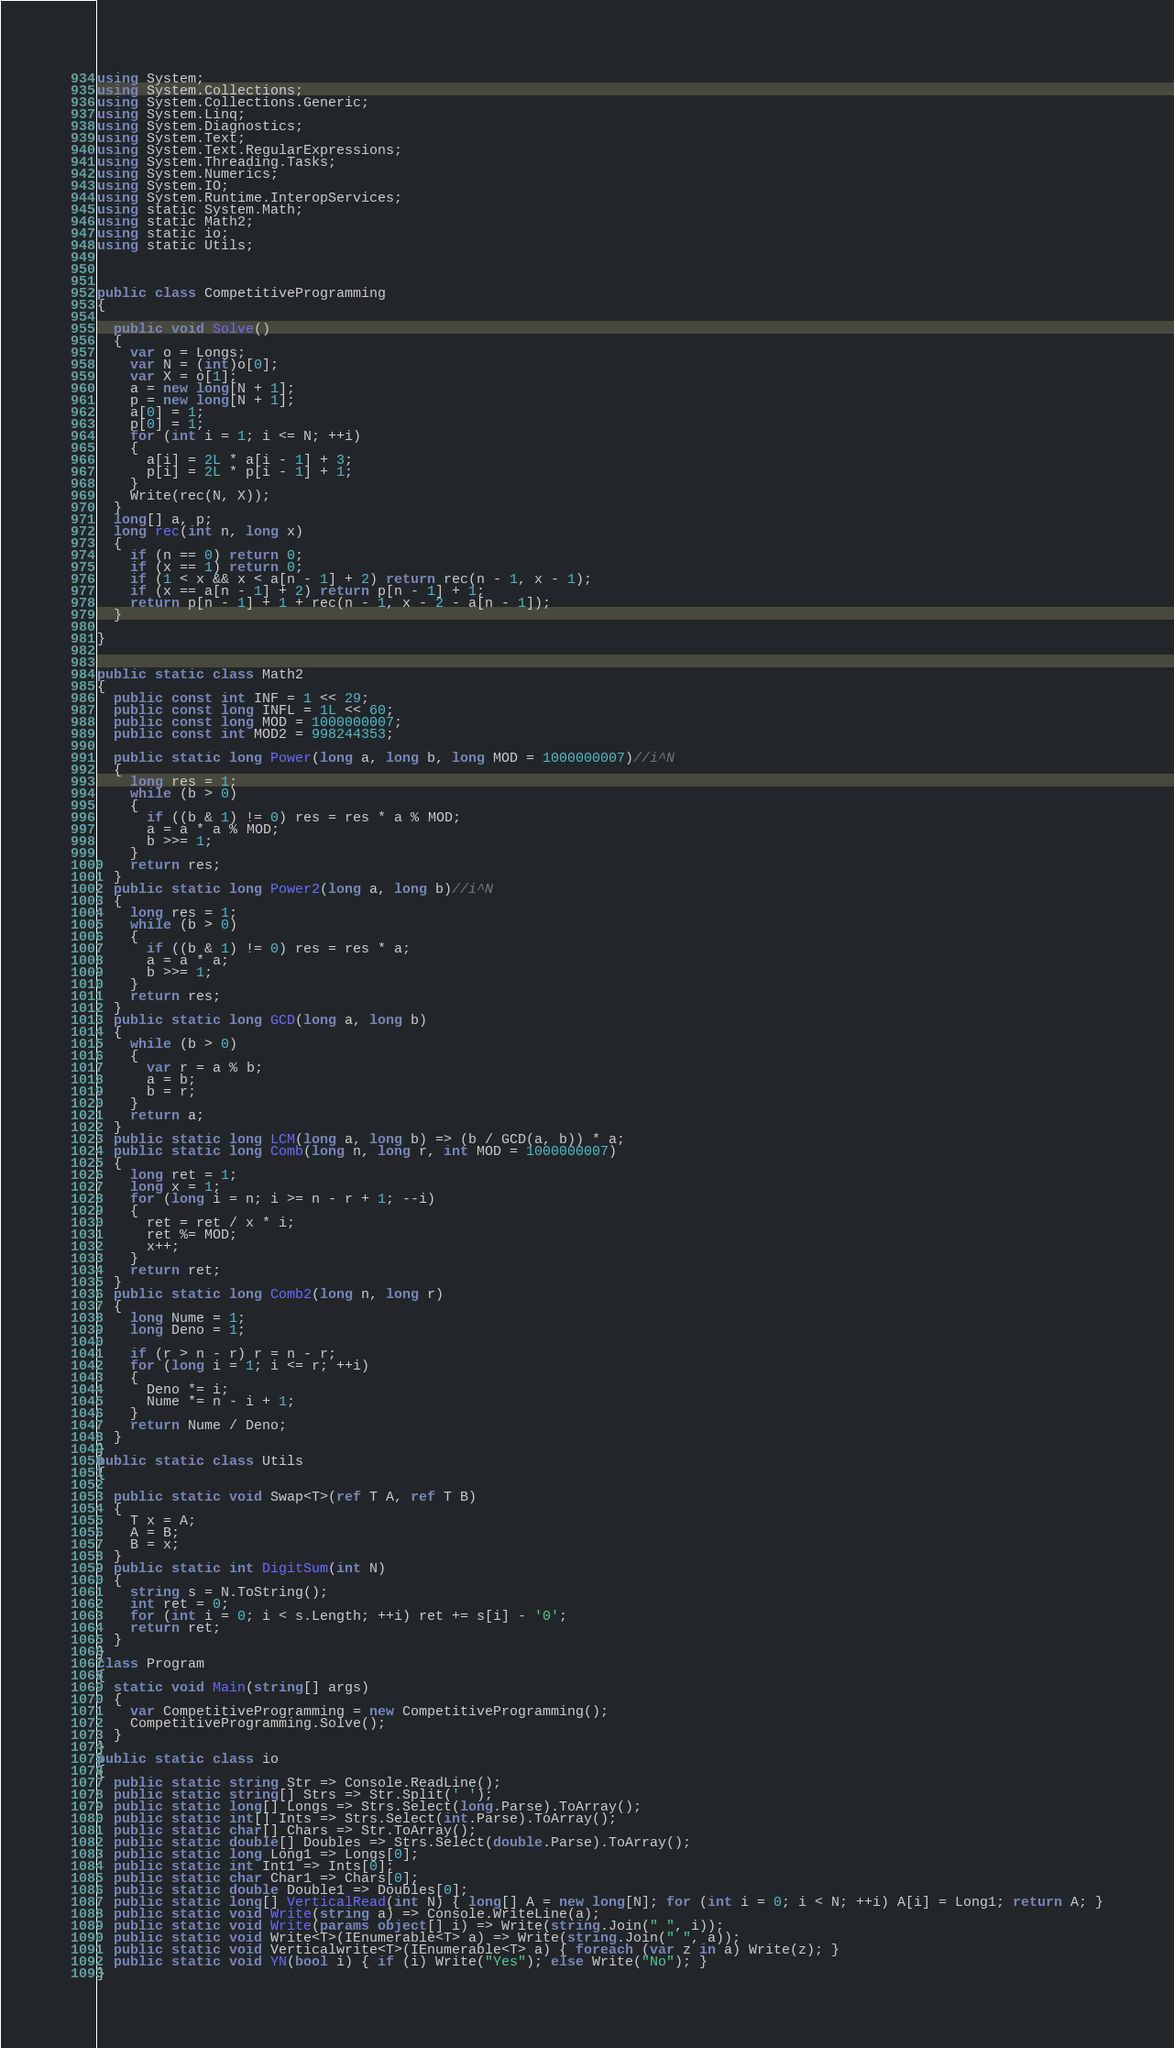<code> <loc_0><loc_0><loc_500><loc_500><_C#_>using System;
using System.Collections;
using System.Collections.Generic;
using System.Linq;
using System.Diagnostics;
using System.Text;
using System.Text.RegularExpressions;
using System.Threading.Tasks;
using System.Numerics;
using System.IO;
using System.Runtime.InteropServices;
using static System.Math;
using static Math2;
using static io;
using static Utils;



public class CompetitiveProgramming
{

  public void Solve()
  {
    var o = Longs;
    var N = (int)o[0];
    var X = o[1];
    a = new long[N + 1];
    p = new long[N + 1];
    a[0] = 1;
    p[0] = 1;
    for (int i = 1; i <= N; ++i)
    {
      a[i] = 2L * a[i - 1] + 3;
      p[i] = 2L * p[i - 1] + 1;
    }
    Write(rec(N, X));
  }
  long[] a, p;
  long rec(int n, long x)
  {
    if (n == 0) return 0;
    if (x == 1) return 0;
    if (1 < x && x < a[n - 1] + 2) return rec(n - 1, x - 1);
    if (x == a[n - 1] + 2) return p[n - 1] + 1;
    return p[n - 1] + 1 + rec(n - 1, x - 2 - a[n - 1]);
  }

}


public static class Math2
{
  public const int INF = 1 << 29;
  public const long INFL = 1L << 60;
  public const long MOD = 1000000007;
  public const int MOD2 = 998244353;

  public static long Power(long a, long b, long MOD = 1000000007)//i^N
  {
    long res = 1;
    while (b > 0)
    {
      if ((b & 1) != 0) res = res * a % MOD;
      a = a * a % MOD;
      b >>= 1;
    }
    return res;
  }
  public static long Power2(long a, long b)//i^N
  {
    long res = 1;
    while (b > 0)
    {
      if ((b & 1) != 0) res = res * a;
      a = a * a;
      b >>= 1;
    }
    return res;
  }
  public static long GCD(long a, long b)
  {
    while (b > 0)
    {
      var r = a % b;
      a = b;
      b = r;
    }
    return a;
  }
  public static long LCM(long a, long b) => (b / GCD(a, b)) * a;
  public static long Comb(long n, long r, int MOD = 1000000007)
  {
    long ret = 1;
    long x = 1;
    for (long i = n; i >= n - r + 1; --i)
    {
      ret = ret / x * i;
      ret %= MOD;
      x++;
    }
    return ret;
  }
  public static long Comb2(long n, long r)
  {
    long Nume = 1;
    long Deno = 1;

    if (r > n - r) r = n - r;
    for (long i = 1; i <= r; ++i)
    {
      Deno *= i;
      Nume *= n - i + 1;
    }
    return Nume / Deno;
  }
}
public static class Utils
{

  public static void Swap<T>(ref T A, ref T B)
  {
    T x = A;
    A = B;
    B = x;
  }
  public static int DigitSum(int N)
  {
    string s = N.ToString();
    int ret = 0;
    for (int i = 0; i < s.Length; ++i) ret += s[i] - '0';
    return ret;
  }
}
class Program
{
  static void Main(string[] args)
  {
    var CompetitiveProgramming = new CompetitiveProgramming();
    CompetitiveProgramming.Solve();
  }
}
public static class io
{
  public static string Str => Console.ReadLine();
  public static string[] Strs => Str.Split(' ');
  public static long[] Longs => Strs.Select(long.Parse).ToArray();
  public static int[] Ints => Strs.Select(int.Parse).ToArray();
  public static char[] Chars => Str.ToArray();
  public static double[] Doubles => Strs.Select(double.Parse).ToArray();
  public static long Long1 => Longs[0];
  public static int Int1 => Ints[0];
  public static char Char1 => Chars[0];
  public static double Double1 => Doubles[0];
  public static long[] VerticalRead(int N) { long[] A = new long[N]; for (int i = 0; i < N; ++i) A[i] = Long1; return A; }
  public static void Write(string a) => Console.WriteLine(a);
  public static void Write(params object[] i) => Write(string.Join(" ", i));
  public static void Write<T>(IEnumerable<T> a) => Write(string.Join(" ", a));
  public static void Verticalwrite<T>(IEnumerable<T> a) { foreach (var z in a) Write(z); }
  public static void YN(bool i) { if (i) Write("Yes"); else Write("No"); }
}</code> 